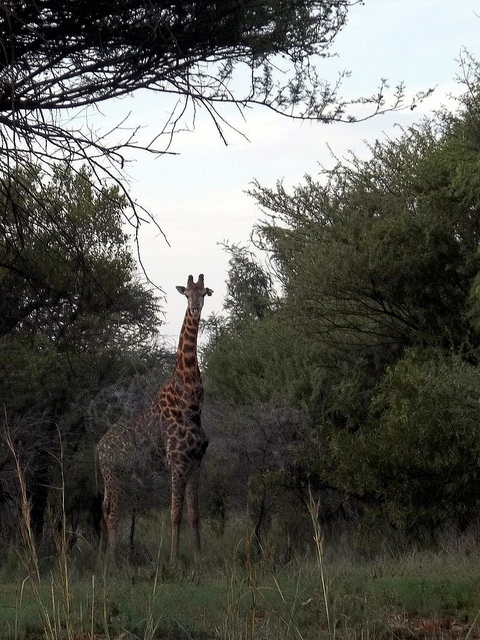Describe the objects in this image and their specific colors. I can see a giraffe in black and gray tones in this image. 